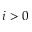Convert formula to latex. <formula><loc_0><loc_0><loc_500><loc_500>i > 0</formula> 